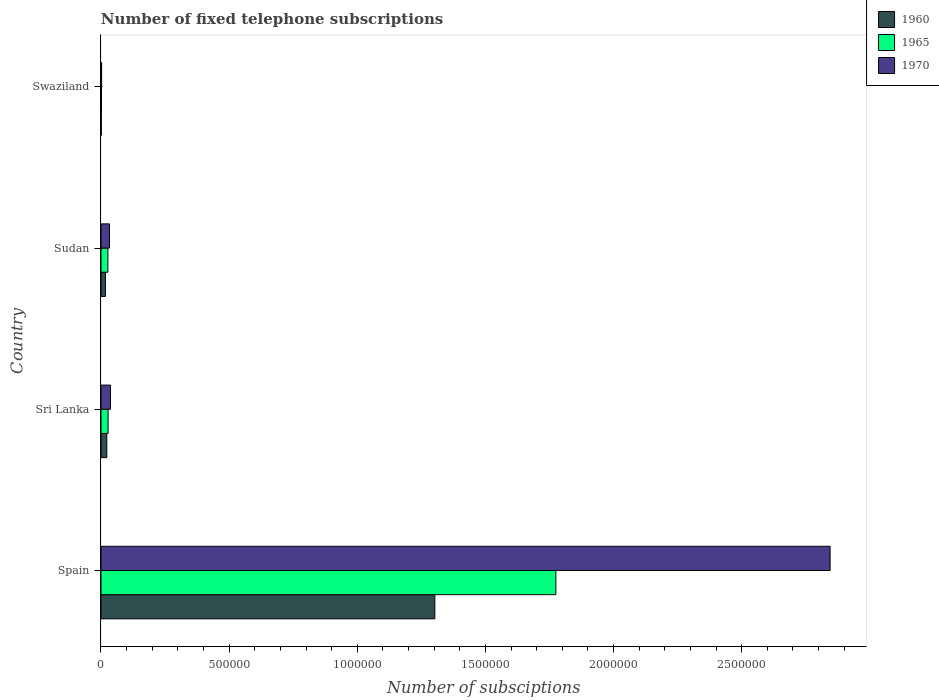How many different coloured bars are there?
Your response must be concise. 3. Are the number of bars per tick equal to the number of legend labels?
Give a very brief answer. Yes. Are the number of bars on each tick of the Y-axis equal?
Give a very brief answer. Yes. How many bars are there on the 3rd tick from the top?
Your answer should be very brief. 3. What is the label of the 3rd group of bars from the top?
Keep it short and to the point. Sri Lanka. In how many cases, is the number of bars for a given country not equal to the number of legend labels?
Your answer should be compact. 0. What is the number of fixed telephone subscriptions in 1970 in Sudan?
Your answer should be very brief. 3.33e+04. Across all countries, what is the maximum number of fixed telephone subscriptions in 1965?
Provide a short and direct response. 1.78e+06. Across all countries, what is the minimum number of fixed telephone subscriptions in 1960?
Offer a very short reply. 1200. In which country was the number of fixed telephone subscriptions in 1965 minimum?
Offer a very short reply. Swaziland. What is the total number of fixed telephone subscriptions in 1970 in the graph?
Your response must be concise. 2.92e+06. What is the difference between the number of fixed telephone subscriptions in 1970 in Sri Lanka and that in Swaziland?
Your answer should be compact. 3.46e+04. What is the difference between the number of fixed telephone subscriptions in 1970 in Sri Lanka and the number of fixed telephone subscriptions in 1960 in Sudan?
Your answer should be very brief. 1.98e+04. What is the average number of fixed telephone subscriptions in 1970 per country?
Provide a short and direct response. 7.29e+05. What is the difference between the number of fixed telephone subscriptions in 1960 and number of fixed telephone subscriptions in 1970 in Sri Lanka?
Ensure brevity in your answer.  -1.43e+04. In how many countries, is the number of fixed telephone subscriptions in 1970 greater than 1500000 ?
Your answer should be very brief. 1. What is the ratio of the number of fixed telephone subscriptions in 1960 in Sri Lanka to that in Swaziland?
Make the answer very short. 18.98. What is the difference between the highest and the second highest number of fixed telephone subscriptions in 1965?
Make the answer very short. 1.75e+06. What is the difference between the highest and the lowest number of fixed telephone subscriptions in 1965?
Your response must be concise. 1.77e+06. What does the 2nd bar from the top in Swaziland represents?
Your answer should be compact. 1965. What does the 1st bar from the bottom in Swaziland represents?
Provide a succinct answer. 1960. Is it the case that in every country, the sum of the number of fixed telephone subscriptions in 1965 and number of fixed telephone subscriptions in 1960 is greater than the number of fixed telephone subscriptions in 1970?
Your response must be concise. Yes. Does the graph contain any zero values?
Give a very brief answer. No. Where does the legend appear in the graph?
Your response must be concise. Top right. What is the title of the graph?
Provide a succinct answer. Number of fixed telephone subscriptions. Does "1964" appear as one of the legend labels in the graph?
Your answer should be compact. No. What is the label or title of the X-axis?
Your response must be concise. Number of subsciptions. What is the Number of subsciptions of 1960 in Spain?
Your response must be concise. 1.30e+06. What is the Number of subsciptions of 1965 in Spain?
Make the answer very short. 1.78e+06. What is the Number of subsciptions in 1970 in Spain?
Make the answer very short. 2.84e+06. What is the Number of subsciptions in 1960 in Sri Lanka?
Your answer should be very brief. 2.28e+04. What is the Number of subsciptions of 1965 in Sri Lanka?
Provide a short and direct response. 2.77e+04. What is the Number of subsciptions of 1970 in Sri Lanka?
Give a very brief answer. 3.71e+04. What is the Number of subsciptions of 1960 in Sudan?
Offer a very short reply. 1.73e+04. What is the Number of subsciptions of 1965 in Sudan?
Offer a terse response. 2.70e+04. What is the Number of subsciptions of 1970 in Sudan?
Provide a succinct answer. 3.33e+04. What is the Number of subsciptions of 1960 in Swaziland?
Offer a terse response. 1200. What is the Number of subsciptions in 1970 in Swaziland?
Give a very brief answer. 2500. Across all countries, what is the maximum Number of subsciptions of 1960?
Make the answer very short. 1.30e+06. Across all countries, what is the maximum Number of subsciptions of 1965?
Your answer should be very brief. 1.78e+06. Across all countries, what is the maximum Number of subsciptions of 1970?
Your answer should be compact. 2.84e+06. Across all countries, what is the minimum Number of subsciptions in 1960?
Offer a very short reply. 1200. Across all countries, what is the minimum Number of subsciptions of 1970?
Your answer should be very brief. 2500. What is the total Number of subsciptions of 1960 in the graph?
Provide a succinct answer. 1.34e+06. What is the total Number of subsciptions in 1965 in the graph?
Your answer should be very brief. 1.83e+06. What is the total Number of subsciptions of 1970 in the graph?
Your answer should be very brief. 2.92e+06. What is the difference between the Number of subsciptions of 1960 in Spain and that in Sri Lanka?
Offer a very short reply. 1.28e+06. What is the difference between the Number of subsciptions of 1965 in Spain and that in Sri Lanka?
Make the answer very short. 1.75e+06. What is the difference between the Number of subsciptions of 1970 in Spain and that in Sri Lanka?
Provide a short and direct response. 2.81e+06. What is the difference between the Number of subsciptions of 1960 in Spain and that in Sudan?
Give a very brief answer. 1.29e+06. What is the difference between the Number of subsciptions of 1965 in Spain and that in Sudan?
Provide a succinct answer. 1.75e+06. What is the difference between the Number of subsciptions of 1970 in Spain and that in Sudan?
Your answer should be very brief. 2.81e+06. What is the difference between the Number of subsciptions in 1960 in Spain and that in Swaziland?
Ensure brevity in your answer.  1.30e+06. What is the difference between the Number of subsciptions in 1965 in Spain and that in Swaziland?
Provide a succinct answer. 1.77e+06. What is the difference between the Number of subsciptions of 1970 in Spain and that in Swaziland?
Your answer should be compact. 2.84e+06. What is the difference between the Number of subsciptions in 1960 in Sri Lanka and that in Sudan?
Make the answer very short. 5433. What is the difference between the Number of subsciptions of 1965 in Sri Lanka and that in Sudan?
Give a very brief answer. 700. What is the difference between the Number of subsciptions of 1970 in Sri Lanka and that in Sudan?
Ensure brevity in your answer.  3800. What is the difference between the Number of subsciptions in 1960 in Sri Lanka and that in Swaziland?
Make the answer very short. 2.16e+04. What is the difference between the Number of subsciptions of 1965 in Sri Lanka and that in Swaziland?
Make the answer very short. 2.57e+04. What is the difference between the Number of subsciptions in 1970 in Sri Lanka and that in Swaziland?
Offer a very short reply. 3.46e+04. What is the difference between the Number of subsciptions in 1960 in Sudan and that in Swaziland?
Provide a short and direct response. 1.61e+04. What is the difference between the Number of subsciptions in 1965 in Sudan and that in Swaziland?
Provide a succinct answer. 2.50e+04. What is the difference between the Number of subsciptions of 1970 in Sudan and that in Swaziland?
Offer a very short reply. 3.08e+04. What is the difference between the Number of subsciptions in 1960 in Spain and the Number of subsciptions in 1965 in Sri Lanka?
Ensure brevity in your answer.  1.28e+06. What is the difference between the Number of subsciptions of 1960 in Spain and the Number of subsciptions of 1970 in Sri Lanka?
Your answer should be compact. 1.27e+06. What is the difference between the Number of subsciptions of 1965 in Spain and the Number of subsciptions of 1970 in Sri Lanka?
Provide a short and direct response. 1.74e+06. What is the difference between the Number of subsciptions of 1960 in Spain and the Number of subsciptions of 1965 in Sudan?
Offer a terse response. 1.28e+06. What is the difference between the Number of subsciptions in 1960 in Spain and the Number of subsciptions in 1970 in Sudan?
Provide a short and direct response. 1.27e+06. What is the difference between the Number of subsciptions in 1965 in Spain and the Number of subsciptions in 1970 in Sudan?
Ensure brevity in your answer.  1.74e+06. What is the difference between the Number of subsciptions in 1960 in Spain and the Number of subsciptions in 1965 in Swaziland?
Keep it short and to the point. 1.30e+06. What is the difference between the Number of subsciptions of 1960 in Spain and the Number of subsciptions of 1970 in Swaziland?
Keep it short and to the point. 1.30e+06. What is the difference between the Number of subsciptions of 1965 in Spain and the Number of subsciptions of 1970 in Swaziland?
Offer a terse response. 1.77e+06. What is the difference between the Number of subsciptions of 1960 in Sri Lanka and the Number of subsciptions of 1965 in Sudan?
Keep it short and to the point. -4228. What is the difference between the Number of subsciptions in 1960 in Sri Lanka and the Number of subsciptions in 1970 in Sudan?
Give a very brief answer. -1.05e+04. What is the difference between the Number of subsciptions in 1965 in Sri Lanka and the Number of subsciptions in 1970 in Sudan?
Make the answer very short. -5600. What is the difference between the Number of subsciptions of 1960 in Sri Lanka and the Number of subsciptions of 1965 in Swaziland?
Give a very brief answer. 2.08e+04. What is the difference between the Number of subsciptions of 1960 in Sri Lanka and the Number of subsciptions of 1970 in Swaziland?
Offer a very short reply. 2.03e+04. What is the difference between the Number of subsciptions of 1965 in Sri Lanka and the Number of subsciptions of 1970 in Swaziland?
Provide a succinct answer. 2.52e+04. What is the difference between the Number of subsciptions of 1960 in Sudan and the Number of subsciptions of 1965 in Swaziland?
Make the answer very short. 1.53e+04. What is the difference between the Number of subsciptions of 1960 in Sudan and the Number of subsciptions of 1970 in Swaziland?
Your answer should be very brief. 1.48e+04. What is the difference between the Number of subsciptions of 1965 in Sudan and the Number of subsciptions of 1970 in Swaziland?
Keep it short and to the point. 2.45e+04. What is the average Number of subsciptions of 1960 per country?
Make the answer very short. 3.36e+05. What is the average Number of subsciptions of 1965 per country?
Give a very brief answer. 4.58e+05. What is the average Number of subsciptions of 1970 per country?
Your response must be concise. 7.29e+05. What is the difference between the Number of subsciptions of 1960 and Number of subsciptions of 1965 in Spain?
Offer a very short reply. -4.72e+05. What is the difference between the Number of subsciptions in 1960 and Number of subsciptions in 1970 in Spain?
Ensure brevity in your answer.  -1.54e+06. What is the difference between the Number of subsciptions of 1965 and Number of subsciptions of 1970 in Spain?
Make the answer very short. -1.07e+06. What is the difference between the Number of subsciptions of 1960 and Number of subsciptions of 1965 in Sri Lanka?
Provide a short and direct response. -4928. What is the difference between the Number of subsciptions in 1960 and Number of subsciptions in 1970 in Sri Lanka?
Offer a terse response. -1.43e+04. What is the difference between the Number of subsciptions in 1965 and Number of subsciptions in 1970 in Sri Lanka?
Your answer should be compact. -9400. What is the difference between the Number of subsciptions of 1960 and Number of subsciptions of 1965 in Sudan?
Give a very brief answer. -9661. What is the difference between the Number of subsciptions in 1960 and Number of subsciptions in 1970 in Sudan?
Provide a short and direct response. -1.60e+04. What is the difference between the Number of subsciptions of 1965 and Number of subsciptions of 1970 in Sudan?
Provide a short and direct response. -6300. What is the difference between the Number of subsciptions of 1960 and Number of subsciptions of 1965 in Swaziland?
Make the answer very short. -800. What is the difference between the Number of subsciptions in 1960 and Number of subsciptions in 1970 in Swaziland?
Your answer should be very brief. -1300. What is the difference between the Number of subsciptions of 1965 and Number of subsciptions of 1970 in Swaziland?
Your answer should be very brief. -500. What is the ratio of the Number of subsciptions of 1960 in Spain to that in Sri Lanka?
Offer a very short reply. 57.21. What is the ratio of the Number of subsciptions of 1965 in Spain to that in Sri Lanka?
Make the answer very short. 64.08. What is the ratio of the Number of subsciptions of 1970 in Spain to that in Sri Lanka?
Provide a short and direct response. 76.68. What is the ratio of the Number of subsciptions of 1960 in Spain to that in Sudan?
Give a very brief answer. 75.13. What is the ratio of the Number of subsciptions in 1965 in Spain to that in Sudan?
Ensure brevity in your answer.  65.74. What is the ratio of the Number of subsciptions in 1970 in Spain to that in Sudan?
Offer a very short reply. 85.44. What is the ratio of the Number of subsciptions of 1960 in Spain to that in Swaziland?
Provide a short and direct response. 1085.62. What is the ratio of the Number of subsciptions in 1965 in Spain to that in Swaziland?
Offer a terse response. 887.5. What is the ratio of the Number of subsciptions in 1970 in Spain to that in Swaziland?
Offer a terse response. 1138. What is the ratio of the Number of subsciptions in 1960 in Sri Lanka to that in Sudan?
Provide a short and direct response. 1.31. What is the ratio of the Number of subsciptions of 1965 in Sri Lanka to that in Sudan?
Provide a short and direct response. 1.03. What is the ratio of the Number of subsciptions in 1970 in Sri Lanka to that in Sudan?
Give a very brief answer. 1.11. What is the ratio of the Number of subsciptions of 1960 in Sri Lanka to that in Swaziland?
Provide a short and direct response. 18.98. What is the ratio of the Number of subsciptions in 1965 in Sri Lanka to that in Swaziland?
Your response must be concise. 13.85. What is the ratio of the Number of subsciptions of 1970 in Sri Lanka to that in Swaziland?
Your answer should be very brief. 14.84. What is the ratio of the Number of subsciptions in 1960 in Sudan to that in Swaziland?
Provide a short and direct response. 14.45. What is the ratio of the Number of subsciptions in 1970 in Sudan to that in Swaziland?
Offer a very short reply. 13.32. What is the difference between the highest and the second highest Number of subsciptions of 1960?
Keep it short and to the point. 1.28e+06. What is the difference between the highest and the second highest Number of subsciptions in 1965?
Make the answer very short. 1.75e+06. What is the difference between the highest and the second highest Number of subsciptions of 1970?
Provide a short and direct response. 2.81e+06. What is the difference between the highest and the lowest Number of subsciptions of 1960?
Your answer should be compact. 1.30e+06. What is the difference between the highest and the lowest Number of subsciptions in 1965?
Keep it short and to the point. 1.77e+06. What is the difference between the highest and the lowest Number of subsciptions of 1970?
Offer a terse response. 2.84e+06. 